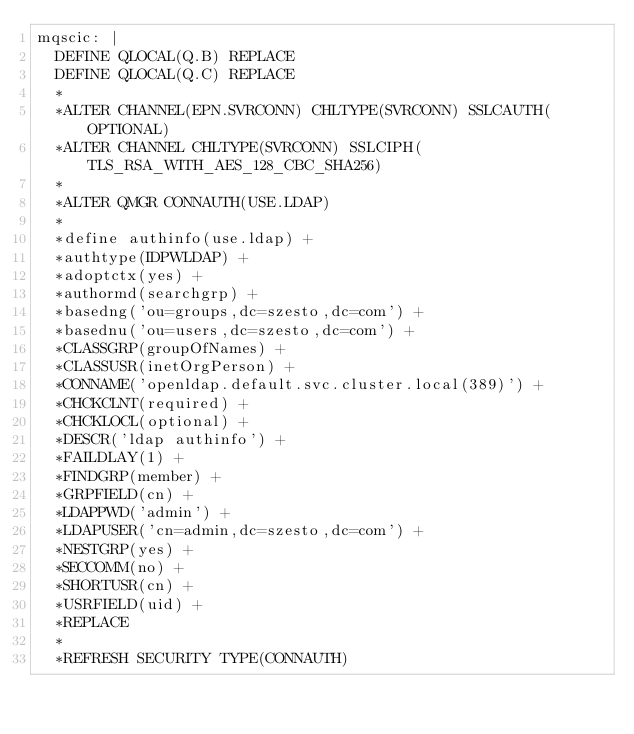Convert code to text. <code><loc_0><loc_0><loc_500><loc_500><_YAML_>mqscic: |
  DEFINE QLOCAL(Q.B) REPLACE
  DEFINE QLOCAL(Q.C) REPLACE
  *
  *ALTER CHANNEL(EPN.SVRCONN) CHLTYPE(SVRCONN) SSLCAUTH(OPTIONAL)
  *ALTER CHANNEL CHLTYPE(SVRCONN) SSLCIPH(TLS_RSA_WITH_AES_128_CBC_SHA256)
  *
  *ALTER QMGR CONNAUTH(USE.LDAP)
  *
  *define authinfo(use.ldap) + 
  *authtype(IDPWLDAP) + 
  *adoptctx(yes) + 
  *authormd(searchgrp) + 
  *basedng('ou=groups,dc=szesto,dc=com') + 
  *basednu('ou=users,dc=szesto,dc=com') + 
  *CLASSGRP(groupOfNames) + 
  *CLASSUSR(inetOrgPerson) + 
  *CONNAME('openldap.default.svc.cluster.local(389)') + 
  *CHCKCLNT(required) + 
  *CHCKLOCL(optional) + 
  *DESCR('ldap authinfo') + 
  *FAILDLAY(1) + 
  *FINDGRP(member) + 
  *GRPFIELD(cn) + 
  *LDAPPWD('admin') + 
  *LDAPUSER('cn=admin,dc=szesto,dc=com') + 
  *NESTGRP(yes) + 
  *SECCOMM(no) + 
  *SHORTUSR(cn) + 
  *USRFIELD(uid) + 
  *REPLACE
  *
  *REFRESH SECURITY TYPE(CONNAUTH)
</code> 